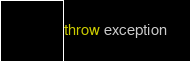Convert code to text. <code><loc_0><loc_0><loc_500><loc_500><_Kotlin_>throw exception</code> 